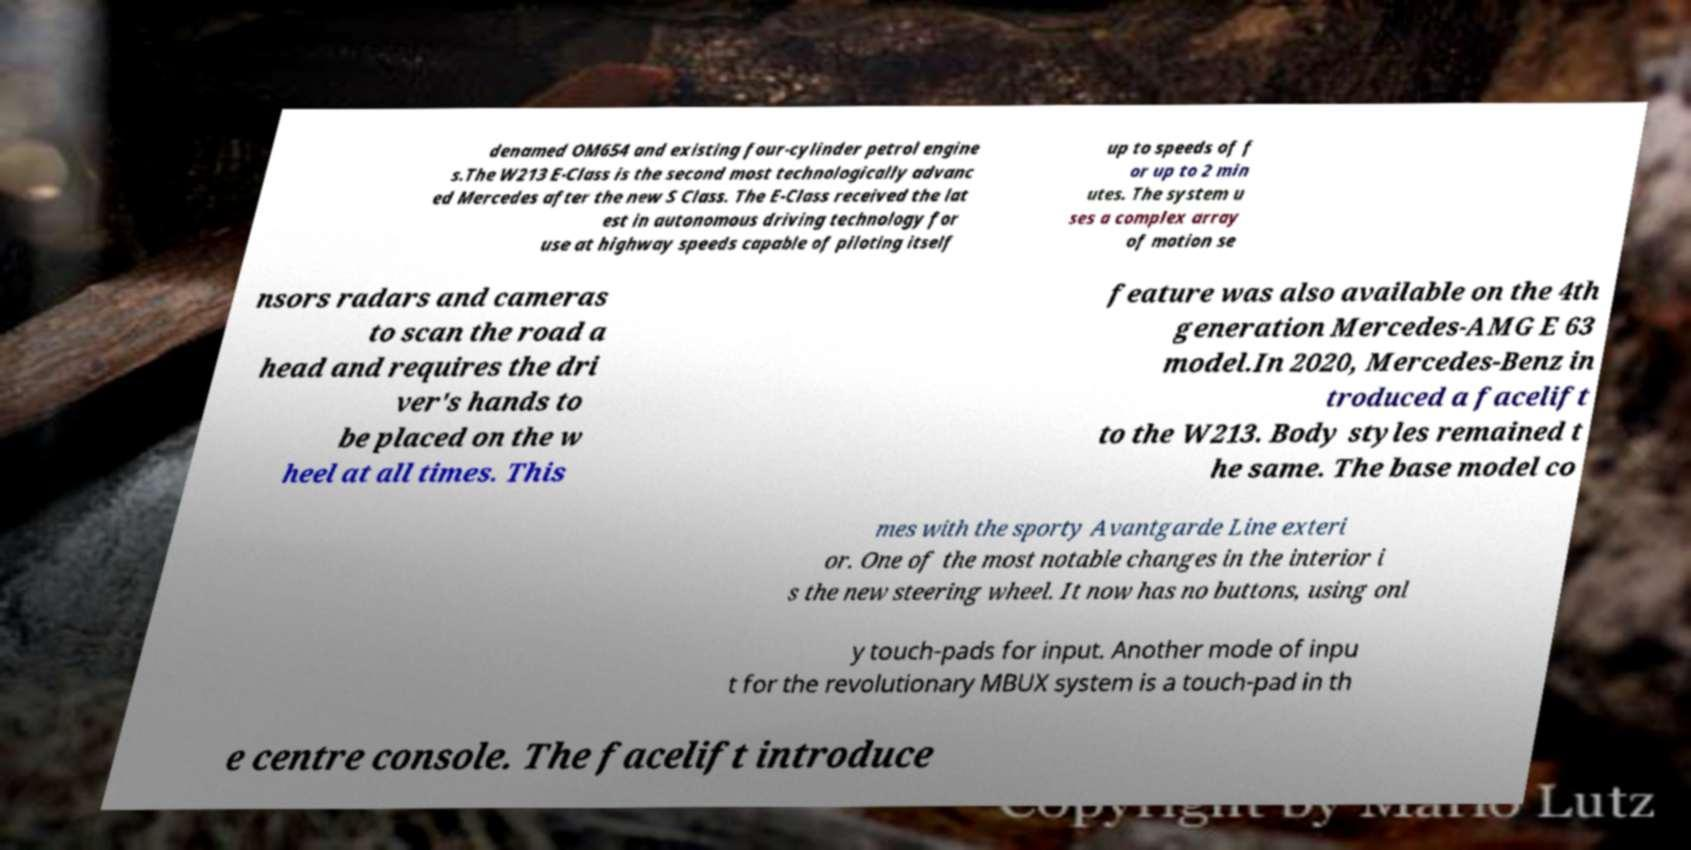Can you read and provide the text displayed in the image?This photo seems to have some interesting text. Can you extract and type it out for me? denamed OM654 and existing four-cylinder petrol engine s.The W213 E-Class is the second most technologically advanc ed Mercedes after the new S Class. The E-Class received the lat est in autonomous driving technology for use at highway speeds capable of piloting itself up to speeds of f or up to 2 min utes. The system u ses a complex array of motion se nsors radars and cameras to scan the road a head and requires the dri ver's hands to be placed on the w heel at all times. This feature was also available on the 4th generation Mercedes-AMG E 63 model.In 2020, Mercedes-Benz in troduced a facelift to the W213. Body styles remained t he same. The base model co mes with the sporty Avantgarde Line exteri or. One of the most notable changes in the interior i s the new steering wheel. It now has no buttons, using onl y touch-pads for input. Another mode of inpu t for the revolutionary MBUX system is a touch-pad in th e centre console. The facelift introduce 